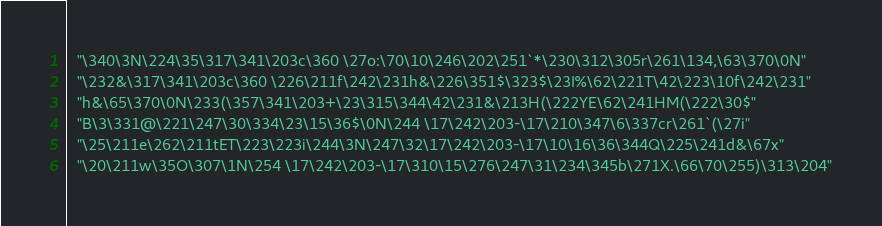Convert code to text. <code><loc_0><loc_0><loc_500><loc_500><_C_>  "\340\3N\224\35\317\341\203c\360 \27o:\70\10\246\202\251`*\230\312\305r\261\134,\63\370\0N"
  "\232&\317\341\203c\360 \226\211f\242\231h&\226\351$\323$\23I%\62\221T\42\223\10f\242\231"
  "h&\65\370\0N\233(\357\341\203+\23\315\344\42\231&\213H(\222YE\62\241HM(\222\30$"
  "B\3\331@\221\247\30\334\23\15\36$\0N\244 \17\242\203-\17\210\347\6\337cr\261`(\27i"
  "\25\211e\262\211tET\223\223i\244\3N\247\32\17\242\203-\17\10\16\36\344Q\225\241d&\67x"
  "\20\211w\35O\307\1N\254 \17\242\203-\17\310\15\276\247\31\234\345b\271X.\66\70\255)\313\204"</code> 